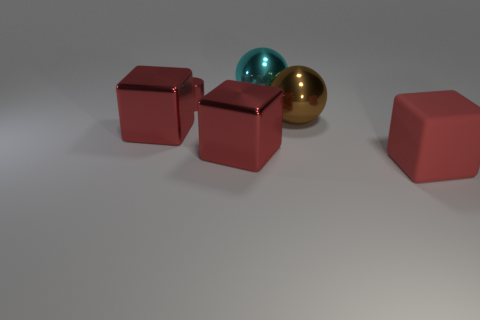Is the number of shiny objects less than the number of big red matte blocks?
Provide a short and direct response. No. Do the metallic object that is left of the tiny metallic thing and the big matte cube have the same color?
Ensure brevity in your answer.  Yes. What number of red rubber cubes are the same size as the cylinder?
Your answer should be compact. 0. Is there a metal object of the same color as the tiny shiny cylinder?
Provide a short and direct response. Yes. Are the big brown object and the cyan ball made of the same material?
Provide a short and direct response. Yes. How many other large objects have the same shape as the rubber object?
Offer a terse response. 2. What shape is the large cyan thing that is made of the same material as the red cylinder?
Ensure brevity in your answer.  Sphere. There is a shiny block in front of the object that is left of the tiny metallic cylinder; what color is it?
Make the answer very short. Red. Do the shiny cylinder and the large matte thing have the same color?
Your answer should be compact. Yes. What is the large sphere behind the large sphere that is in front of the cyan object made of?
Ensure brevity in your answer.  Metal. 